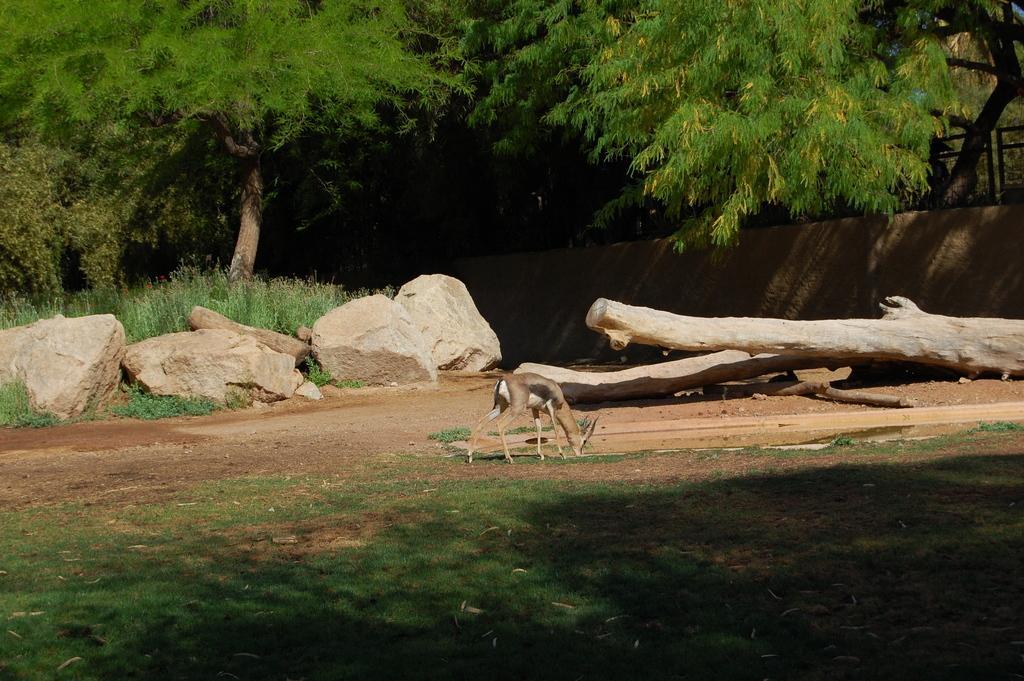Could you give a brief overview of what you see in this image? In the center of the image, there is a deer and on the right, we can see some wood. On the left, there are rocks. In the background, there are trees. At the bottom, there is ground. 